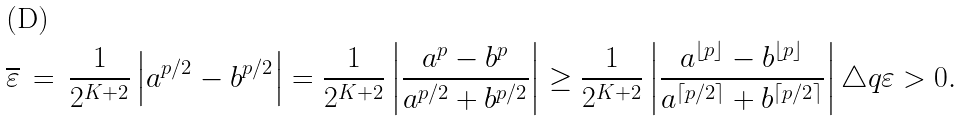<formula> <loc_0><loc_0><loc_500><loc_500>\overline { \varepsilon } \, = \, \frac { 1 } { 2 ^ { K + 2 } } \left | a ^ { p / 2 } - b ^ { p / 2 } \right | = \frac { 1 } { 2 ^ { K + 2 } } \left | \frac { a ^ { p } - b ^ { p } } { a ^ { p / 2 } + b ^ { p / 2 } } \right | & \geq \frac { 1 } { 2 ^ { K + 2 } } \left | \frac { a ^ { \lfloor p \rfloor } - b ^ { \lfloor p \rfloor } } { a ^ { \lceil p / 2 \rceil } + b ^ { \lceil p / 2 \rceil } } \right | \triangle q \varepsilon > 0 .</formula> 